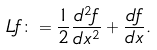Convert formula to latex. <formula><loc_0><loc_0><loc_500><loc_500>L f \colon = \frac { 1 } { 2 } \frac { d ^ { 2 } f } { d x ^ { 2 } } + \frac { d f } { d x } .</formula> 